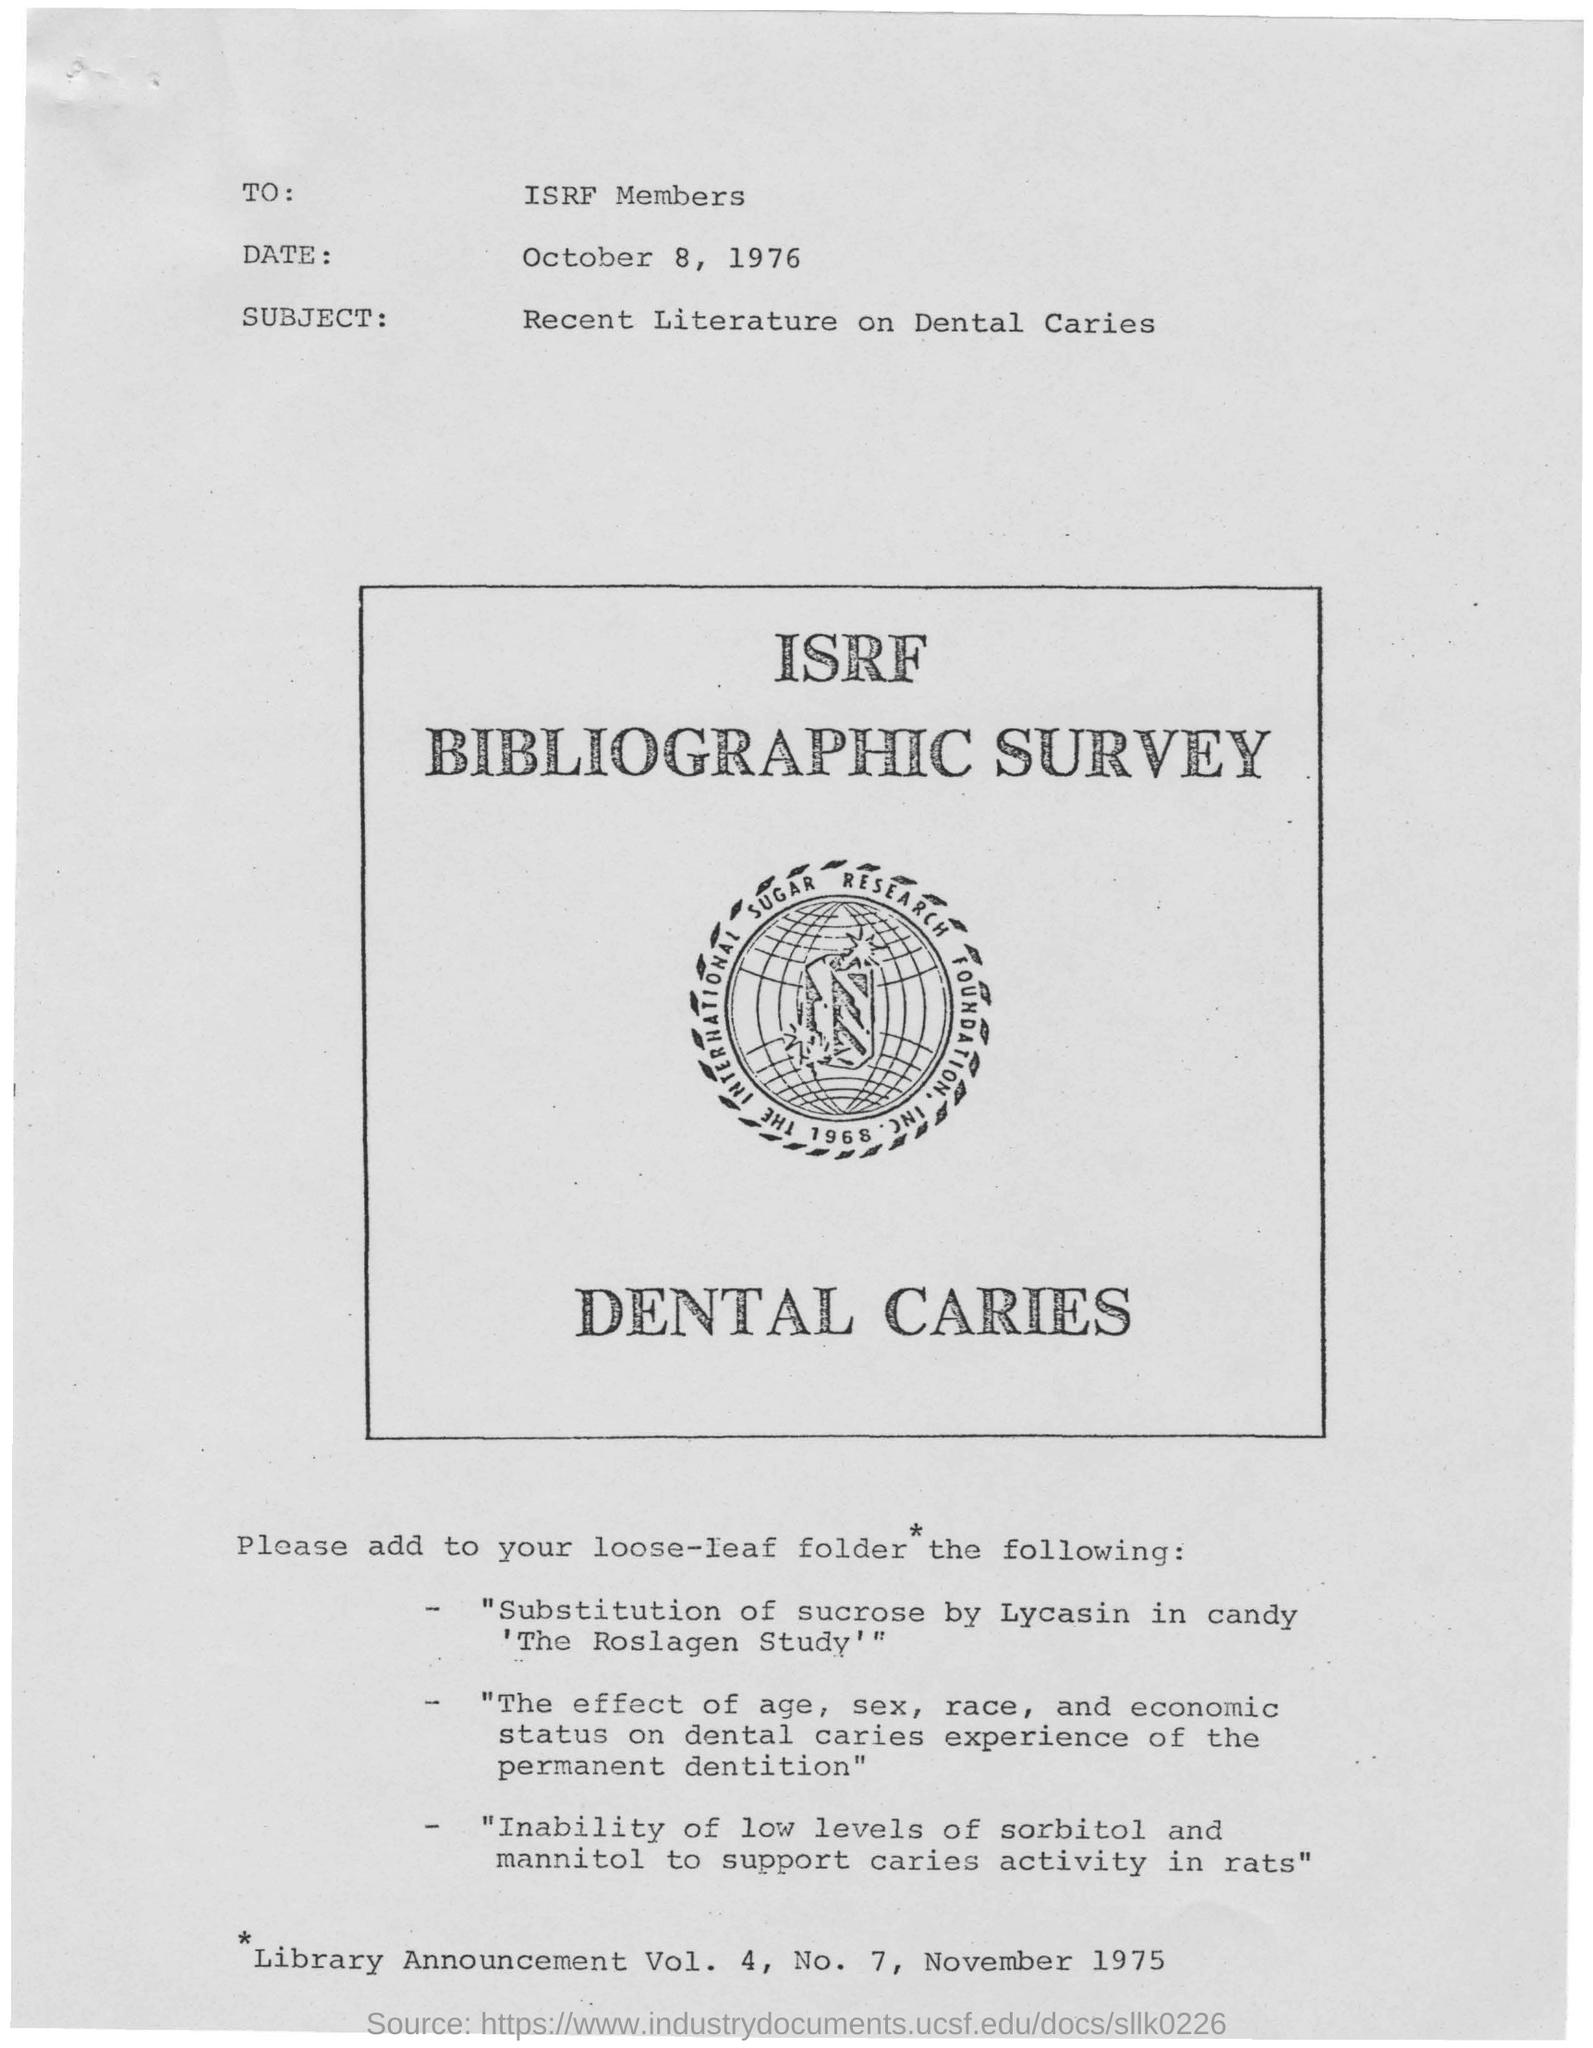Point out several critical features in this image. The date mentioned at the top is October 8, 1976. The letter is about recent literature on dental caries. This letter is addressed to ISRF members. 